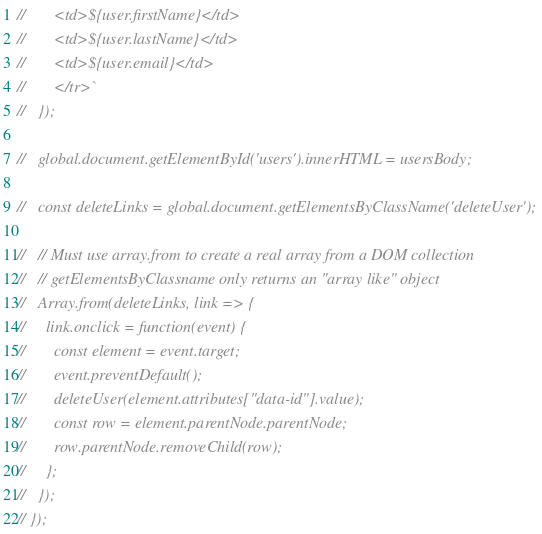<code> <loc_0><loc_0><loc_500><loc_500><_JavaScript_>//       <td>${user.firstName}</td>
//       <td>${user.lastName}</td>
//       <td>${user.email}</td>
//       </tr>`
//   });

//   global.document.getElementById('users').innerHTML = usersBody;

//   const deleteLinks = global.document.getElementsByClassName('deleteUser');

//   // Must use array.from to create a real array from a DOM collection
//   // getElementsByClassname only returns an "array like" object
//   Array.from(deleteLinks, link => {
//     link.onclick = function(event) {
//       const element = event.target;
//       event.preventDefault();
//       deleteUser(element.attributes["data-id"].value);
//       const row = element.parentNode.parentNode;
//       row.parentNode.removeChild(row);
//     };
//   });
// });
</code> 